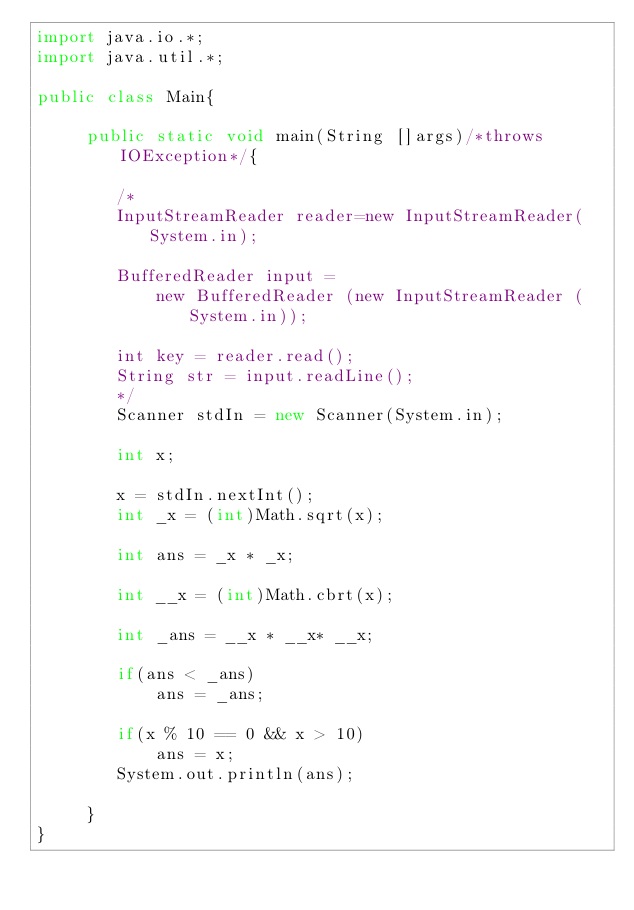Convert code to text. <code><loc_0><loc_0><loc_500><loc_500><_Java_>import java.io.*;
import java.util.*;

public class Main{

     public static void main(String []args)/*throws IOException*/{
        
        /*
        InputStreamReader reader=new InputStreamReader(System.in);
 
        BufferedReader input =
			new BufferedReader (new InputStreamReader (System.in));
			
		int key = reader.read();
		String str = input.readLine();
		*/
		Scanner stdIn = new Scanner(System.in);
		
		int x;
		
		x = stdIn.nextInt();
	    int _x = (int)Math.sqrt(x);
	    
		int ans = _x * _x;
		
		int __x = (int)Math.cbrt(x);
		
		int _ans = __x * __x* __x;
		
		if(ans < _ans)
		    ans = _ans;
		    
		if(x % 10 == 0 && x > 10)
		    ans = x;
		System.out.println(ans);
	
     }
}
</code> 